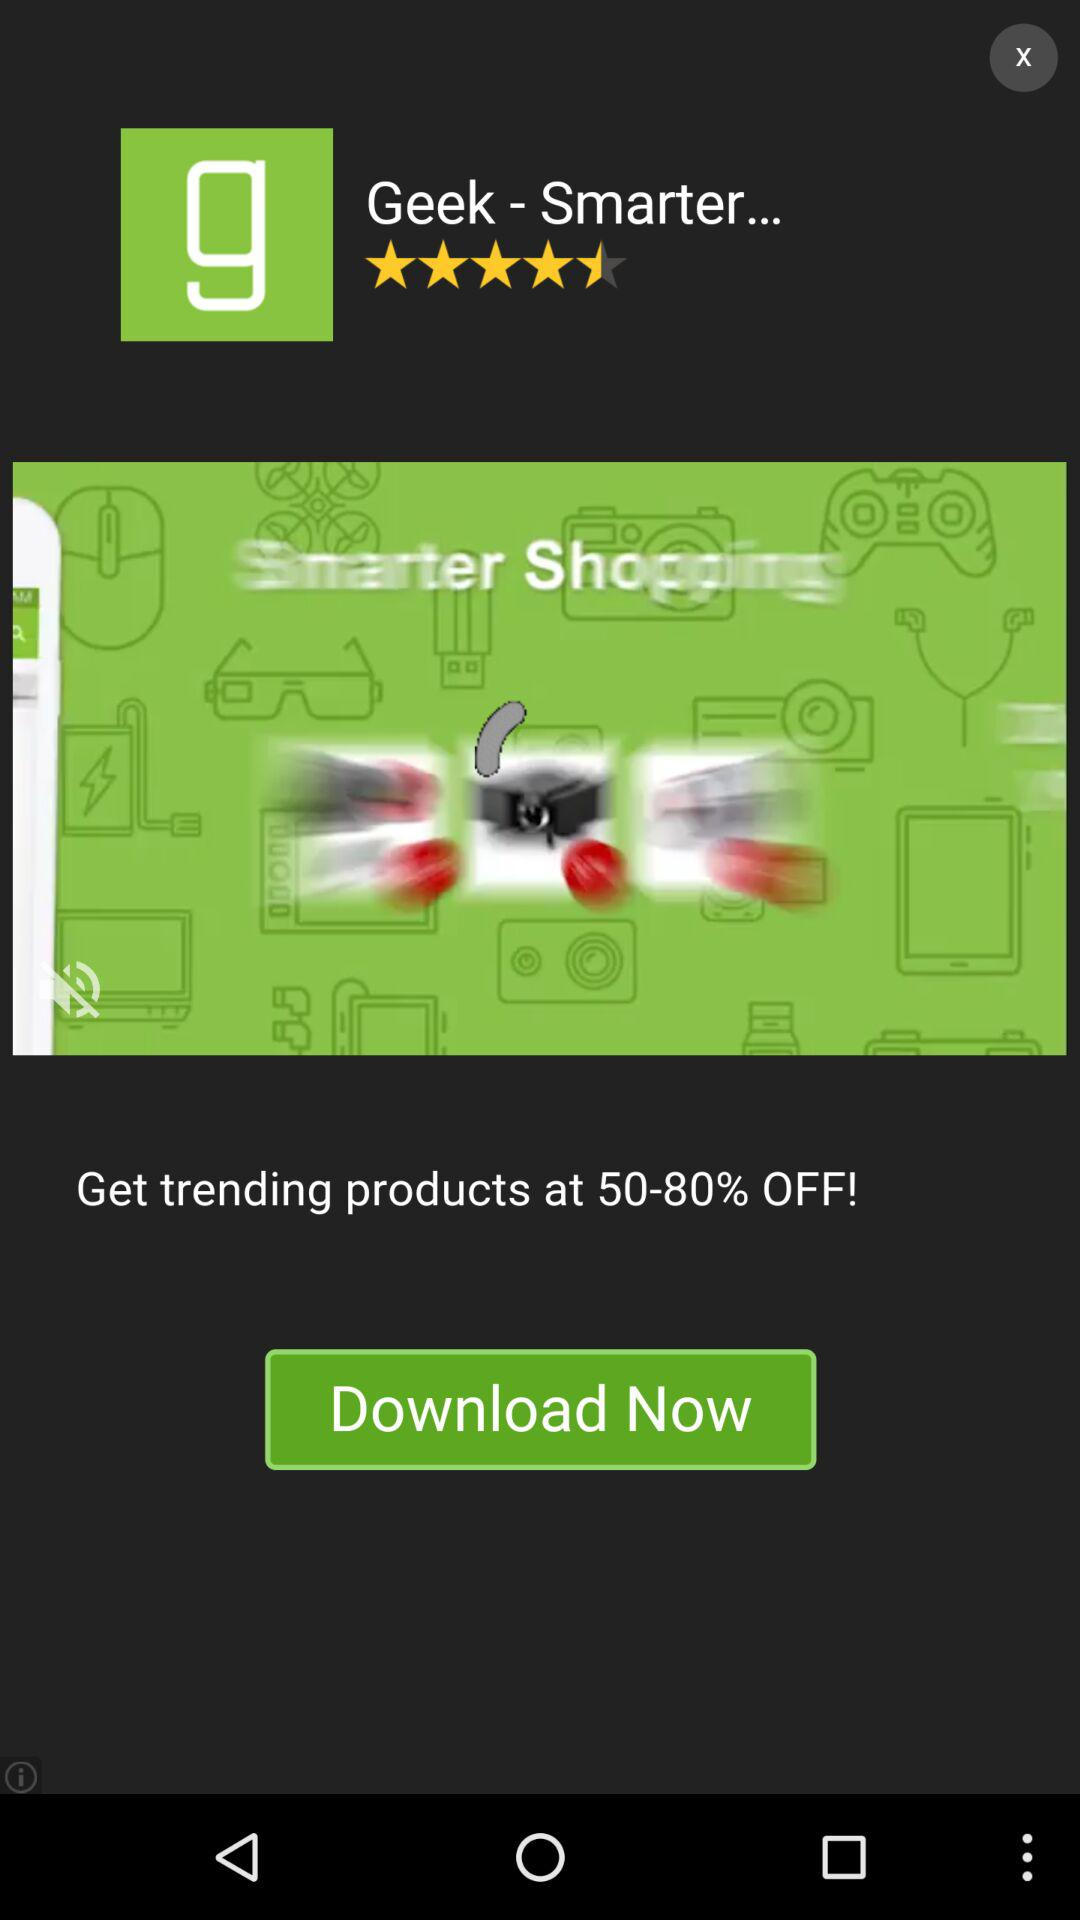How much discount is available on trending products? The discount ranges from 50 to 80 percent. 